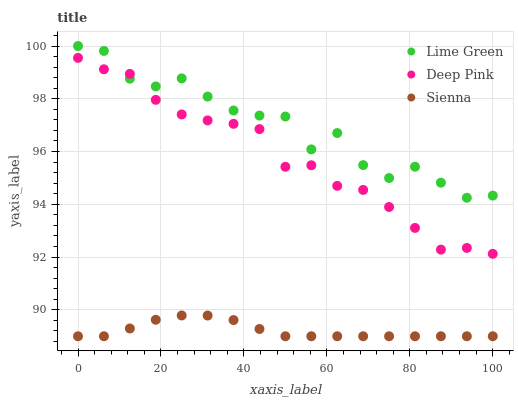Does Sienna have the minimum area under the curve?
Answer yes or no. Yes. Does Lime Green have the maximum area under the curve?
Answer yes or no. Yes. Does Deep Pink have the minimum area under the curve?
Answer yes or no. No. Does Deep Pink have the maximum area under the curve?
Answer yes or no. No. Is Sienna the smoothest?
Answer yes or no. Yes. Is Lime Green the roughest?
Answer yes or no. Yes. Is Deep Pink the smoothest?
Answer yes or no. No. Is Deep Pink the roughest?
Answer yes or no. No. Does Sienna have the lowest value?
Answer yes or no. Yes. Does Deep Pink have the lowest value?
Answer yes or no. No. Does Lime Green have the highest value?
Answer yes or no. Yes. Does Deep Pink have the highest value?
Answer yes or no. No. Is Sienna less than Deep Pink?
Answer yes or no. Yes. Is Lime Green greater than Sienna?
Answer yes or no. Yes. Does Deep Pink intersect Lime Green?
Answer yes or no. Yes. Is Deep Pink less than Lime Green?
Answer yes or no. No. Is Deep Pink greater than Lime Green?
Answer yes or no. No. Does Sienna intersect Deep Pink?
Answer yes or no. No. 